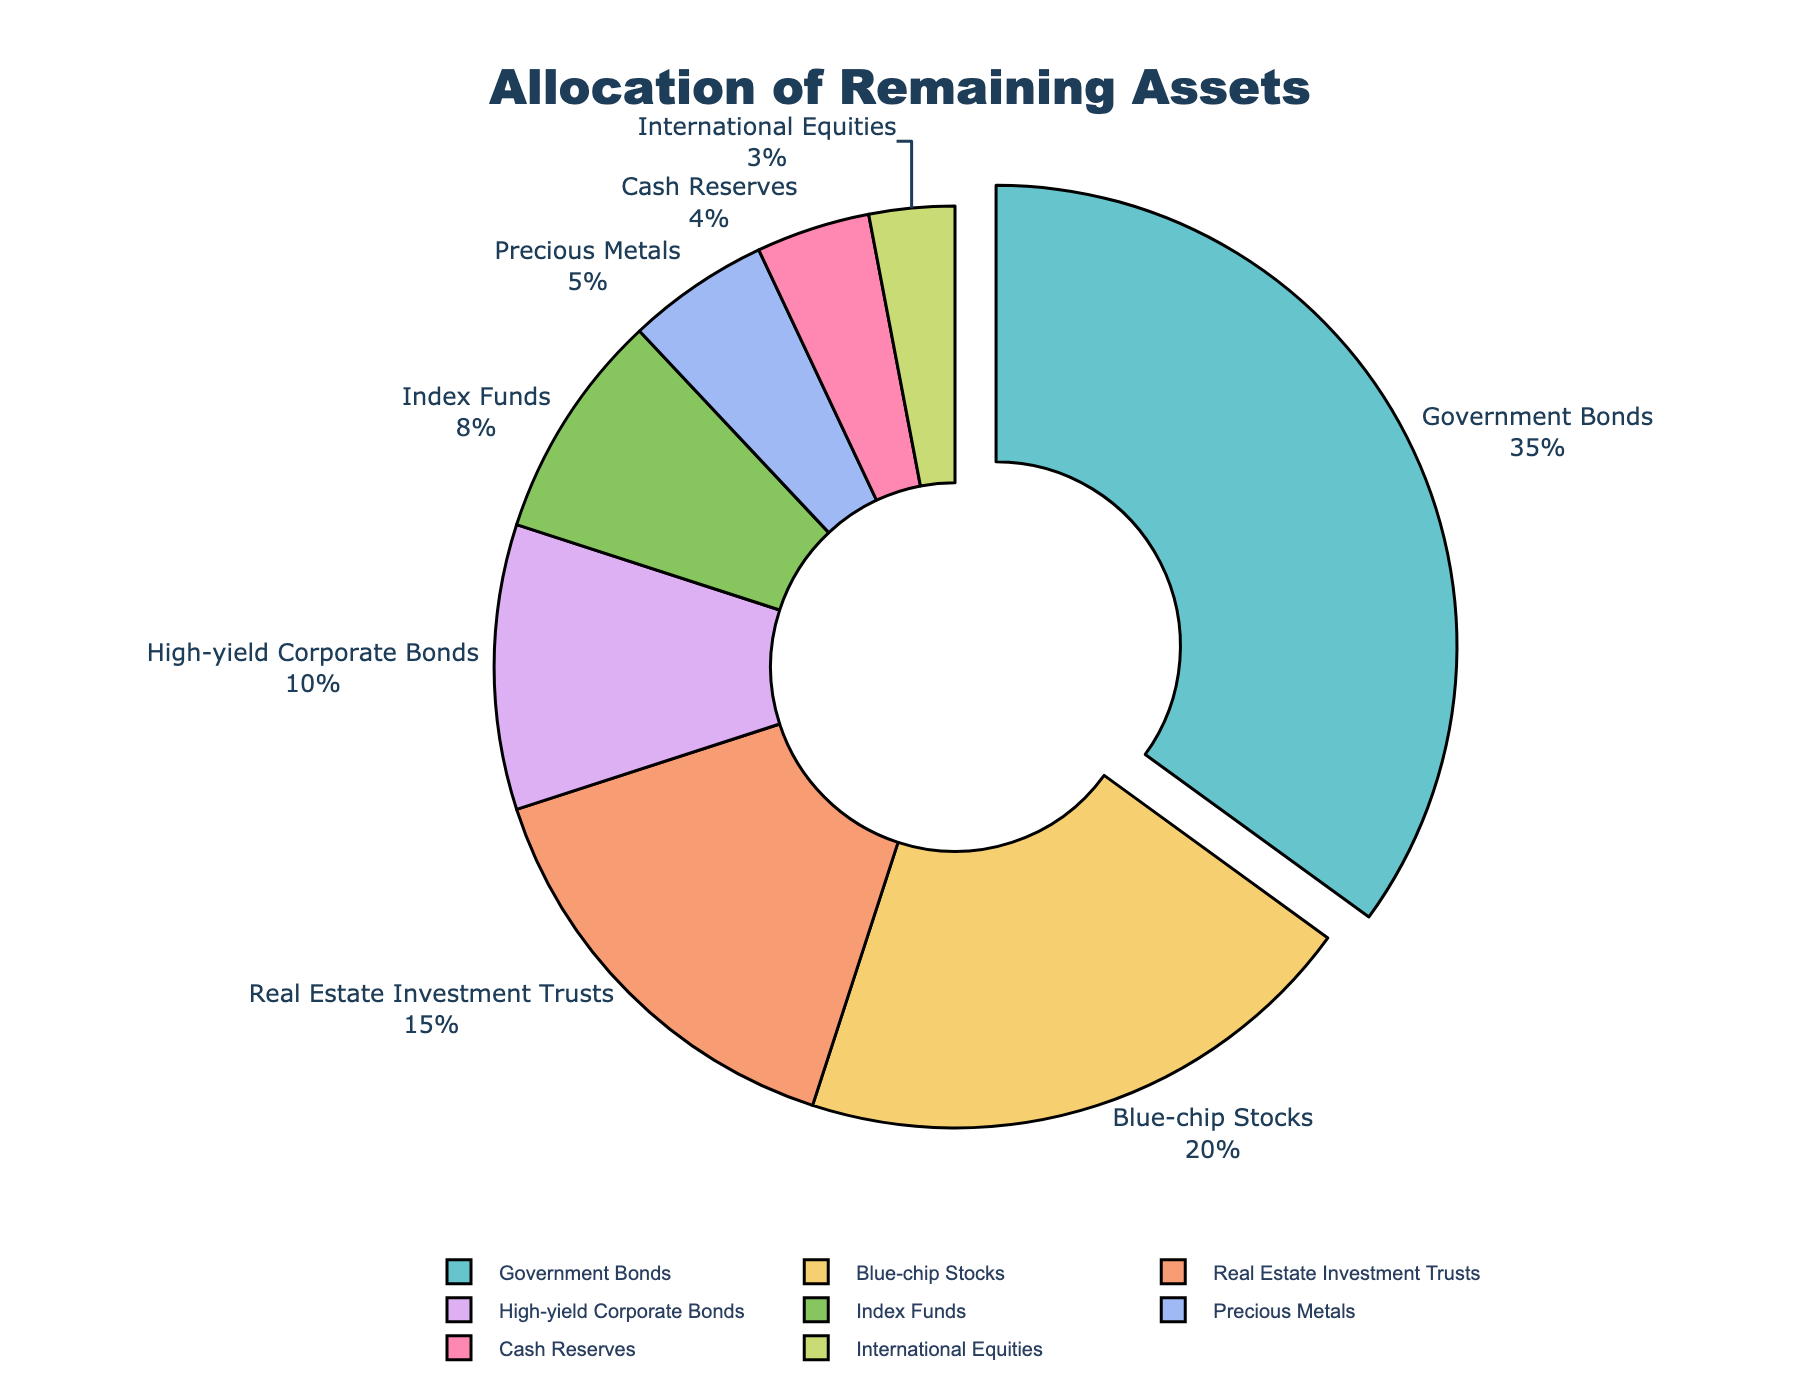How much of the assets are allocated to Government Bonds and Blue-chip Stocks combined? First, we find the percentage of assets allocated to Government Bonds which is 35%, and Blue-chip Stocks, which is 20%. Adding these together: 35% + 20% = 55%.
Answer: 55% Which two asset categories have the smallest allocations, and what is their combined total? The two smallest allocations are International Equities at 3% and Cash Reserves at 4%. Adding them together: 3% + 4% = 7%.
Answer: International Equities and Cash Reserves, 7% Is the allocation for Real Estate Investment Trusts greater than the allocation for High-yield Corporate Bonds? The allocation for Real Estate Investment Trusts is 15%, and for High-yield Corporate Bonds, it is 10%. Since 15% is greater than 10%, the allocation for Real Estate Investment Trusts is greater.
Answer: Yes What is the difference in allocation between the asset category with the highest allocation and the one with the lowest? The highest allocation is for Government Bonds at 35%, and the lowest is for International Equities at 3%. The difference is: 35% - 3% = 32%.
Answer: 32% Which asset category is shown with the most prominent visual emphasis in the pie chart, and why? Government Bonds are shown with the most prominent visual emphasis because it has the highest allocation of 35%, and this section would be "pulled out" slightly from the pie chart for emphasis.
Answer: Government Bonds What percentage of assets are allocated across Blue-chip Stocks and Index Funds? The percentage for Blue-chip Stocks is 20% and for Index Funds is 8%. Adding these together: 20% + 8% = 28%.
Answer: 28% Are Precious Metals allocated more, less, or equal compared to Cash Reserves? Precious Metals are allocated 5%, and Cash Reserves are allocated 4%. Since 5% is greater than 4%, Precious Metals are allocated more.
Answer: More What is the sum of the allocations for High-yield Corporate Bonds, Index Funds, and Precious Metals? High-yield Corporate Bonds are 10%, Index Funds are 8%, and Precious Metals are 5%. Adding these together: 10% + 8% + 5% = 23%.
Answer: 23% Which asset category falls in between Blue-chip Stocks and High-yield Corporate Bonds in terms of allocation, and what is its percentage? The asset categories arranged by allocation are: Government Bonds (35%), Blue-chip Stocks (20%), Real Estate Investment Trusts (15%), then High-yield Corporate Bonds (10%). So, the category between Blue-chip Stocks and High-yield Corporate Bonds is Real Estate Investment Trusts, at 15%.
Answer: Real Estate Investment Trusts, 15% 